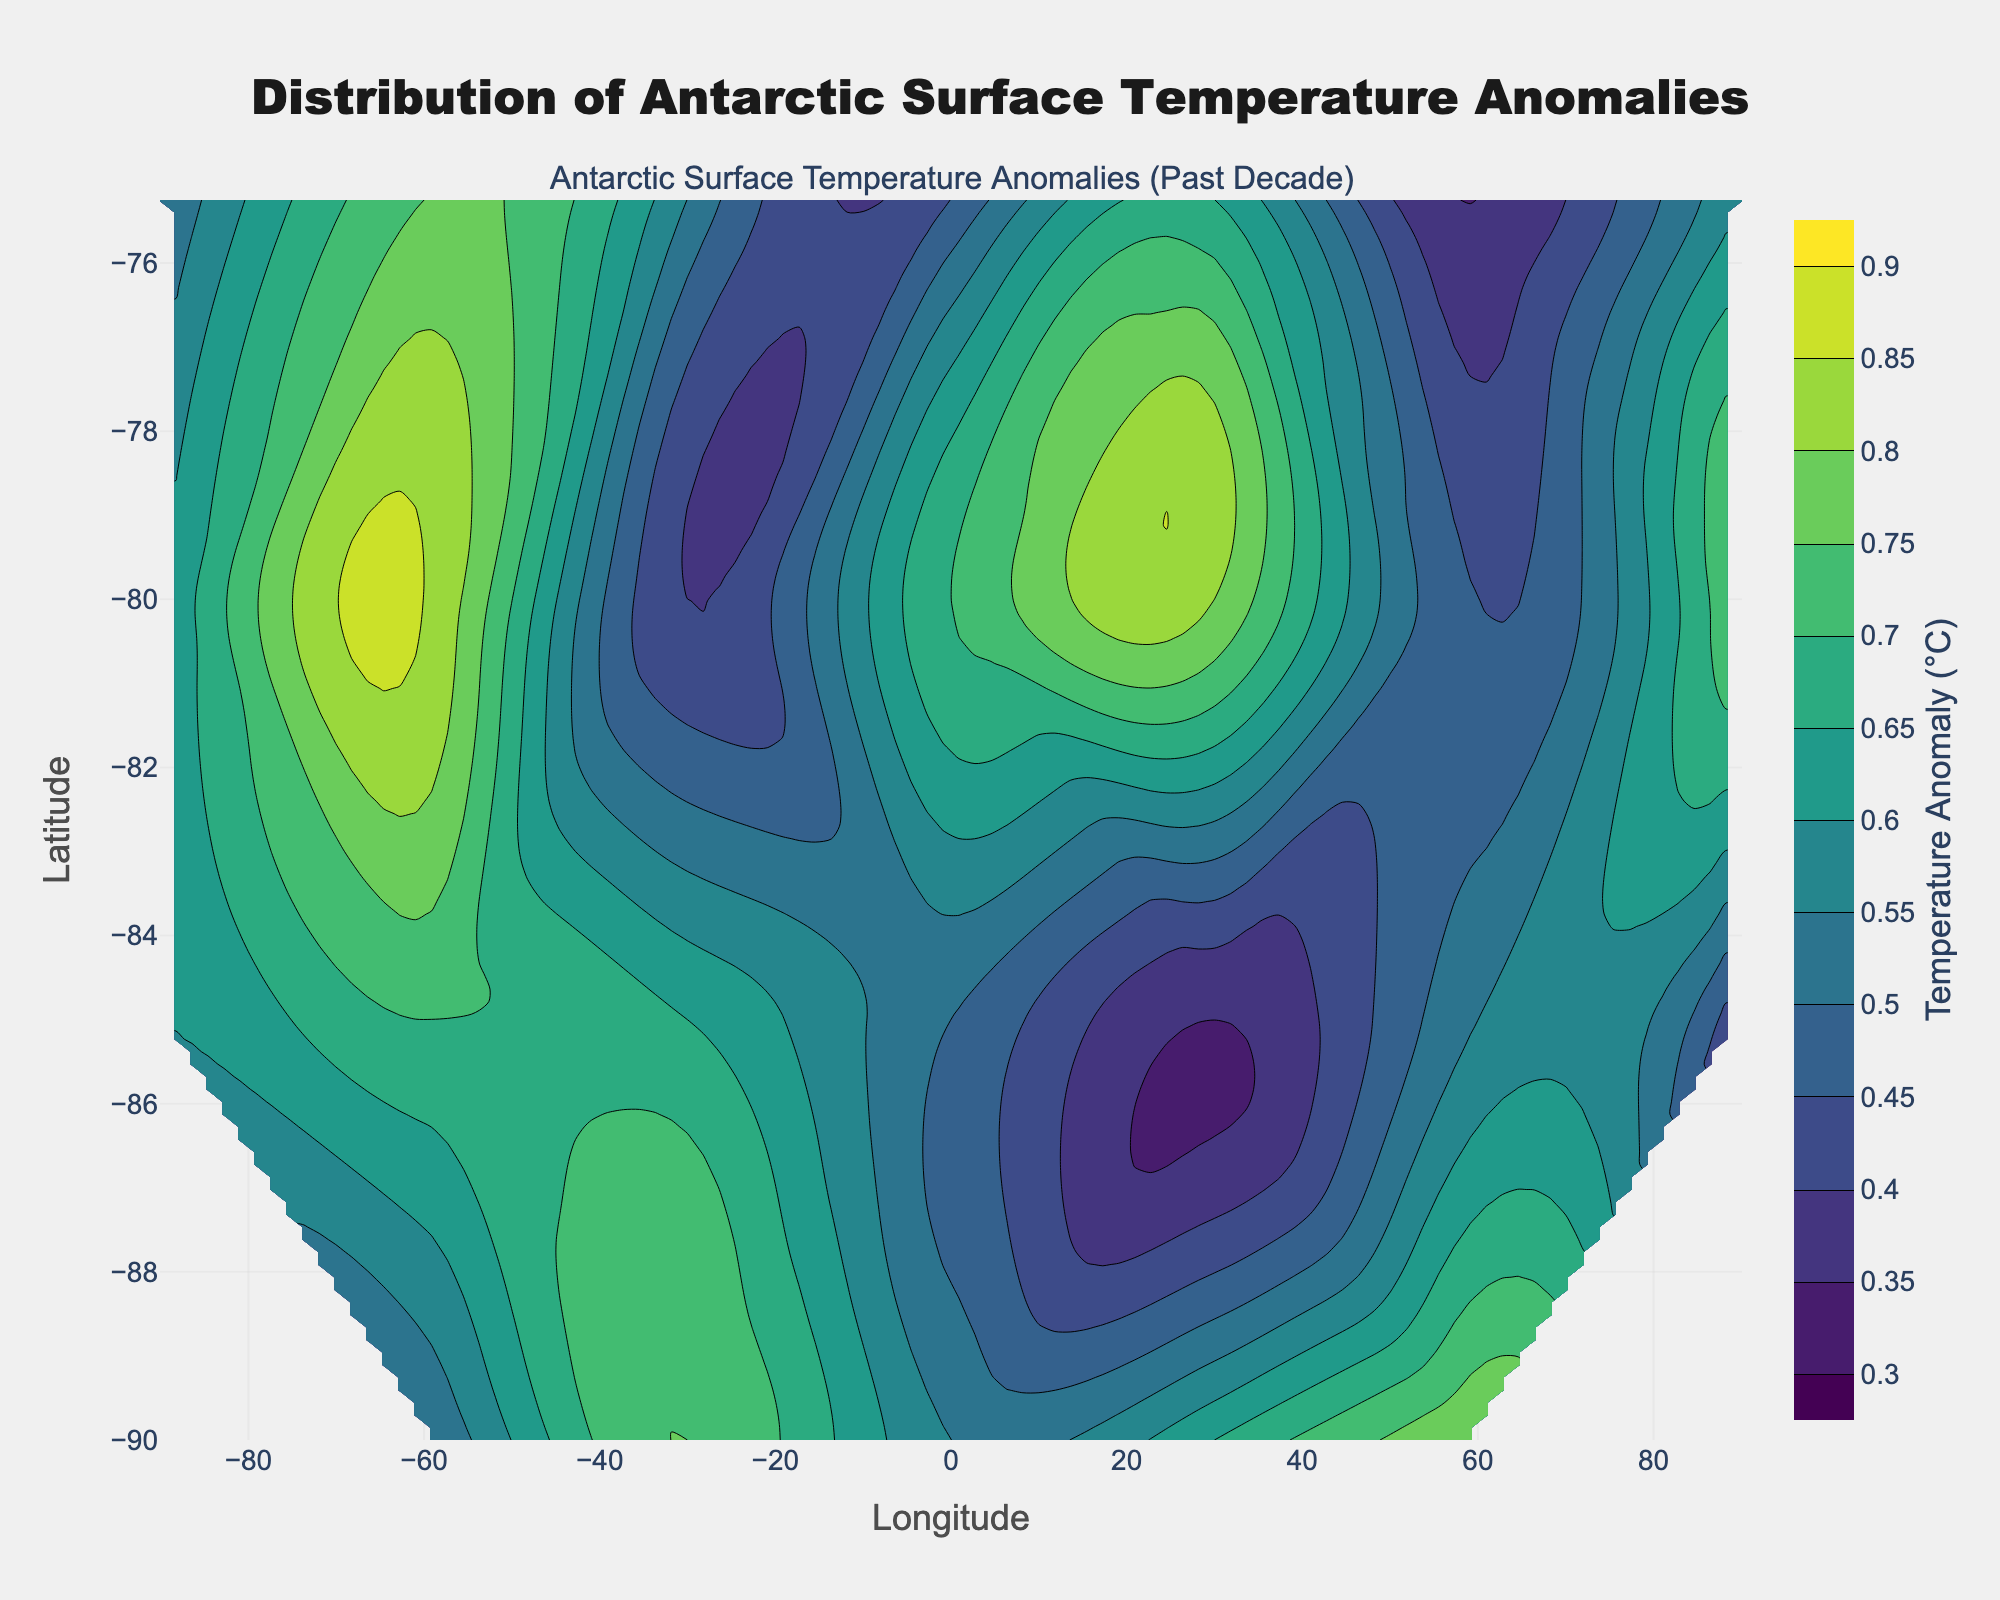What is the title of this plot? The title is usually placed at the top of the figure and provides a brief description of what the plot represents.
Answer: Distribution of Antarctic Surface Temperature Anomalies What are the labels on the x and y axes? The labels on the axes denote what each axis represents. These labels help us understand what the horizontal and vertical dimensions correspond to.
Answer: Longitude and Latitude Which color represents the lowest temperature anomaly? The contour plot uses a colorscale to represent various temperature anomalies. By examining the colorscale, we can identify which color corresponds to the lowest value.
Answer: Dark blue Is there a specific temperature anomaly value that frequently appears in the plot? By closely examining the contour lines, one can identify the values that more frequently appear, especially where the lines are densely packed.
Answer: 0.75°C Which region has the highest temperature anomaly visible in the plot? To find the region with the highest temperature anomaly, look for the contour lines representing the highest value, and locate the area they encompass.
Answer: Near -80 degrees Latitude and -60 degrees Longitude How does the temperature anomaly at -75.2500 Latitude, 30.071 Longitude compare to the temperature anomaly at -90.0000 Latitude, 60.000 Longitude? To compare these points, check the figure for their locations and corresponding temperature anomaly values, then compare these values.
Answer: 0.65°C vs. 0.80°C, the anomaly at -90.0000 Latitude, 60.000 Longitude is higher What is the range of temperature anomalies presented in the plot? By looking at the colorbar beside the contour plot, one can see the lowest and highest temperature anomaly values plotted.
Answer: 0.30°C to 0.90°C Is there a significant variation in temperature anomalies near the poles compared to other regions? By observing the density and spread of the contour lines near the top and bottom edges of the plot (which represent the poles), we can determine if there's high variability.
Answer: Yes, especially near the South Pole at -90.0000 Latitude Which area shows more uniform temperature anomalies, -75.2500 Latitude region or -85.0000 Latitude region? Uniformity can be determined by the spacing of contour lines; areas with evenly spaced and fewer contour lines indicate more uniform temperature anomalies.
Answer: -75.2500 Latitude region 